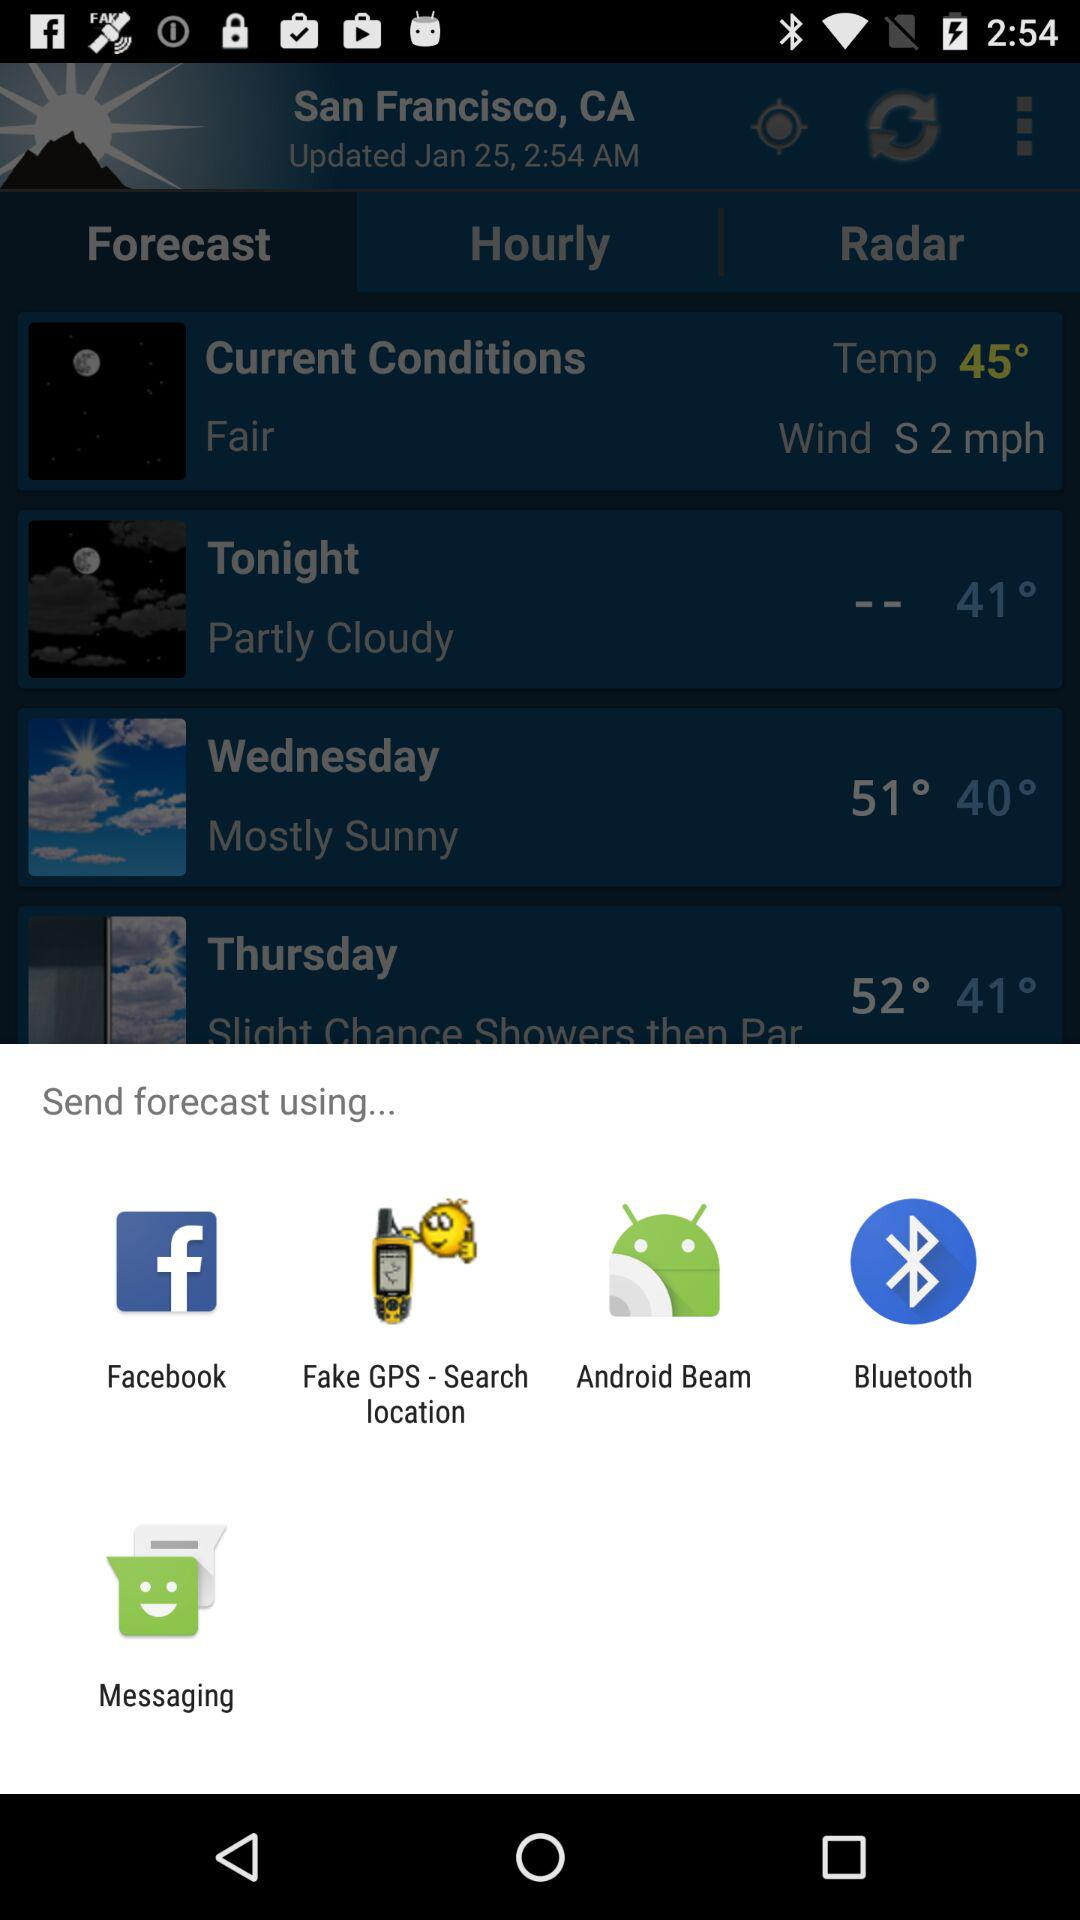What are the options that can be used to send the forecast? The options are "Facebook", "Fake GPS - Search location", "Android Beam", "Bluetooth" and "Messaging". 